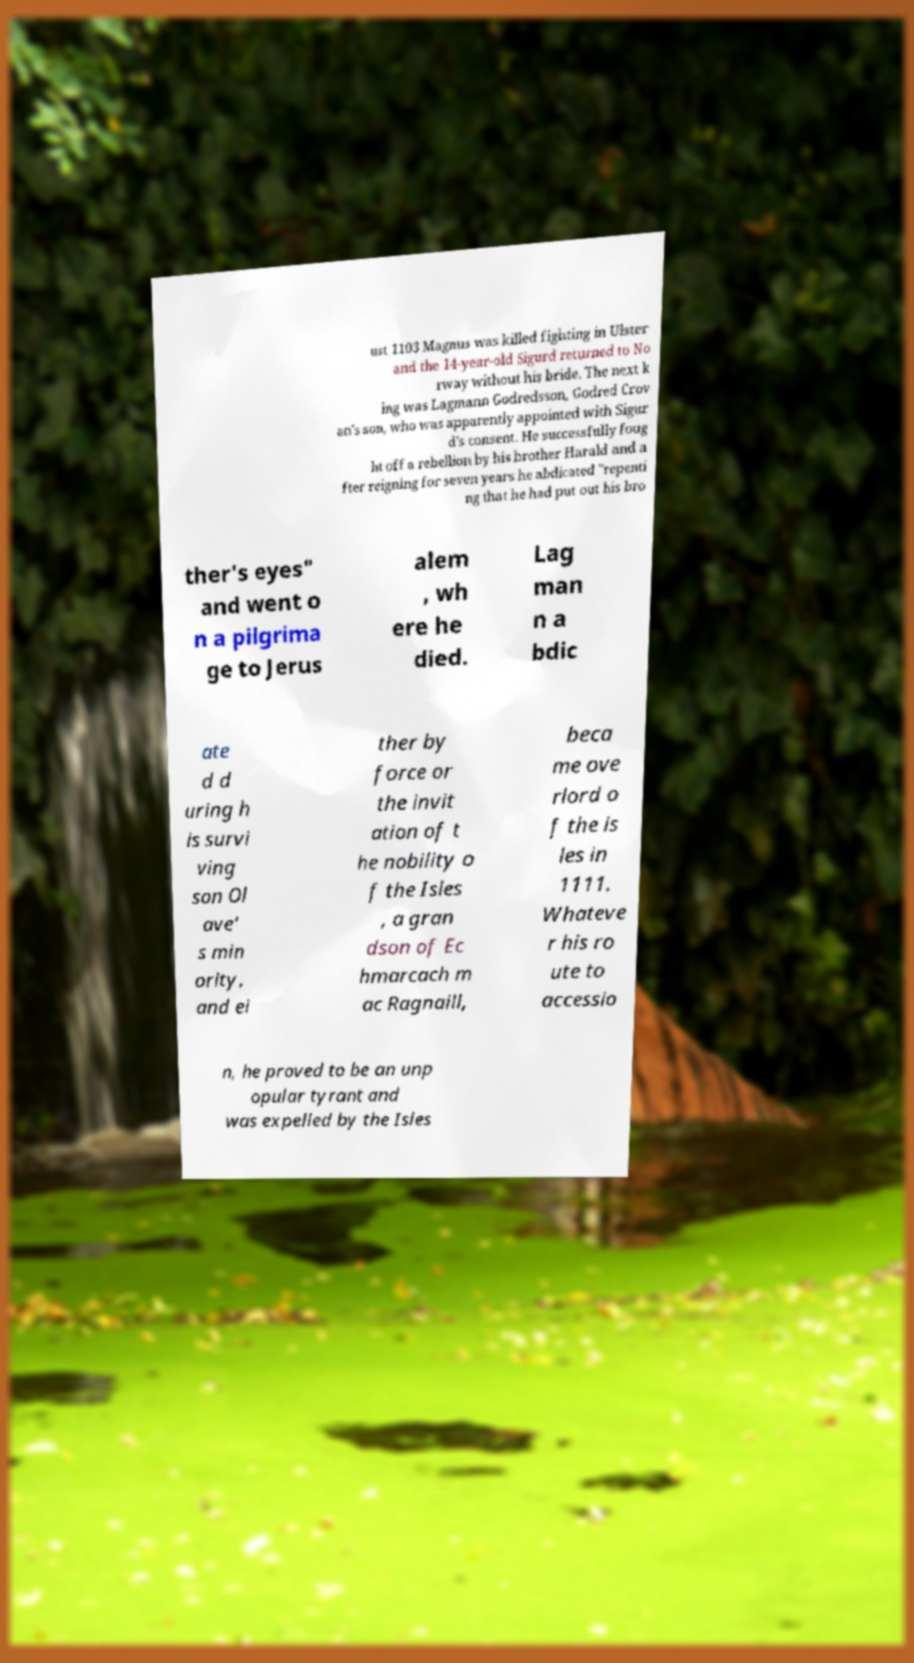Can you read and provide the text displayed in the image?This photo seems to have some interesting text. Can you extract and type it out for me? ust 1103 Magnus was killed fighting in Ulster and the 14-year-old Sigurd returned to No rway without his bride. The next k ing was Lagmann Godredsson, Godred Crov an's son, who was apparently appointed with Sigur d's consent. He successfully foug ht off a rebellion by his brother Harald and a fter reigning for seven years he abdicated "repenti ng that he had put out his bro ther's eyes" and went o n a pilgrima ge to Jerus alem , wh ere he died. Lag man n a bdic ate d d uring h is survi ving son Ol ave' s min ority, and ei ther by force or the invit ation of t he nobility o f the Isles , a gran dson of Ec hmarcach m ac Ragnaill, beca me ove rlord o f the is les in 1111. Whateve r his ro ute to accessio n, he proved to be an unp opular tyrant and was expelled by the Isles 